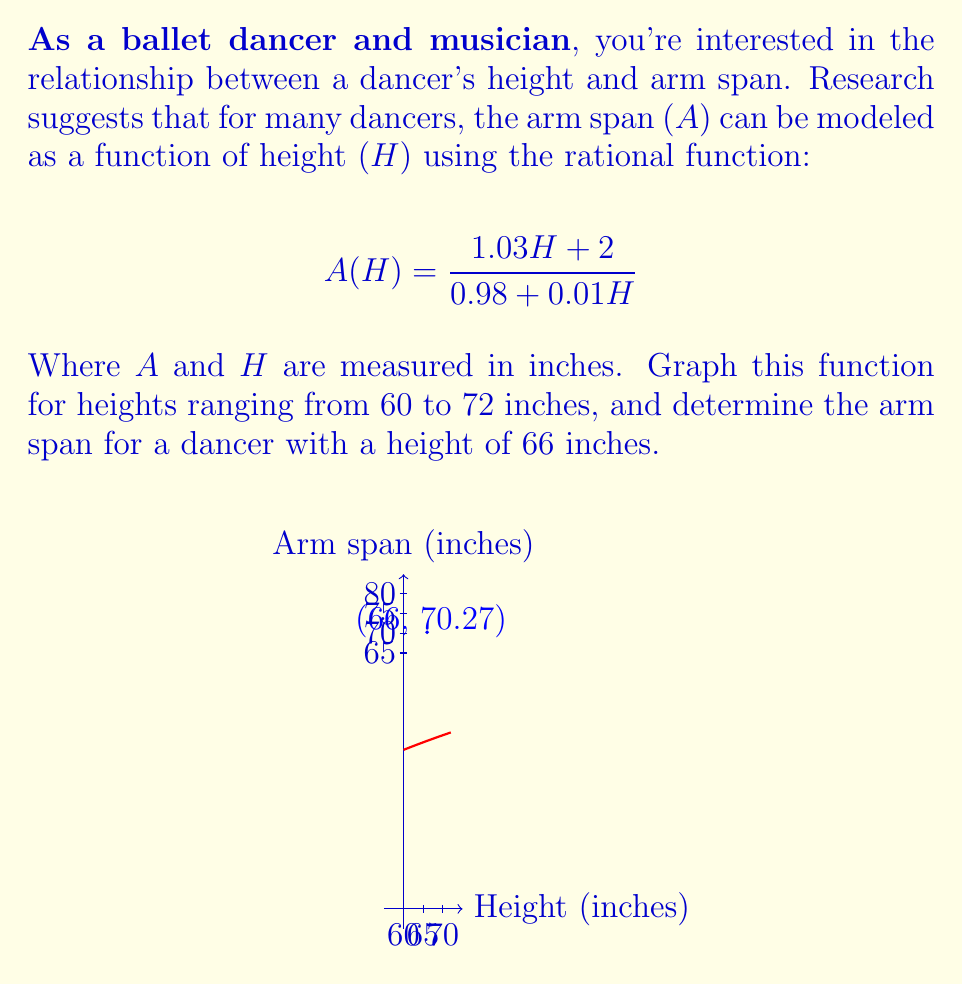Could you help me with this problem? Let's approach this step-by-step:

1) First, we need to graph the function $A(H) = \frac{1.03H + 2}{0.98 + 0.01H}$ for $H$ ranging from 60 to 72 inches.

2) To graph this function, we'll calculate a few points:
   At $H = 60$: $A(60) = \frac{1.03(60) + 2}{0.98 + 0.01(60)} = \frac{63.8}{1.58} \approx 40.38$
   At $H = 66$: $A(66) = \frac{1.03(66) + 2}{0.98 + 0.01(66)} = \frac{70.98}{1.64} \approx 43.28$
   At $H = 72$: $A(72) = \frac{1.03(72) + 2}{0.98 + 0.01(72)} = \frac{76.16}{1.70} \approx 44.80$

3) Plotting these points and connecting them with a smooth curve gives us the graph shown in the question.

4) To determine the arm span for a dancer with a height of 66 inches, we simply need to evaluate $A(66)$:

   $A(66) = \frac{1.03(66) + 2}{0.98 + 0.01(66)} = \frac{70.98}{1.64} \approx 43.28$

5) Therefore, a dancer with a height of 66 inches would have an arm span of approximately 43.28 inches according to this model.
Answer: 43.28 inches 